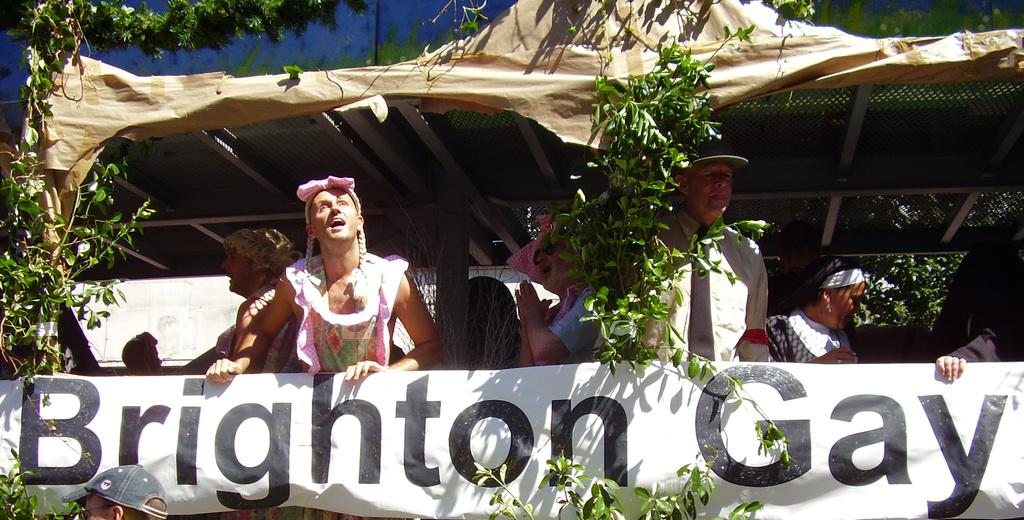What are the people in the image doing under the tent? The people in the image are standing under a tent and holding a banner. What else can be seen in the image besides the people and the tent? There are plants visible in the image. What type of sticks are being used by the minister in the image? There is no minister or sticks present in the image. What role does the cast play in the image? There is no cast or theatrical performance depicted in the image. 